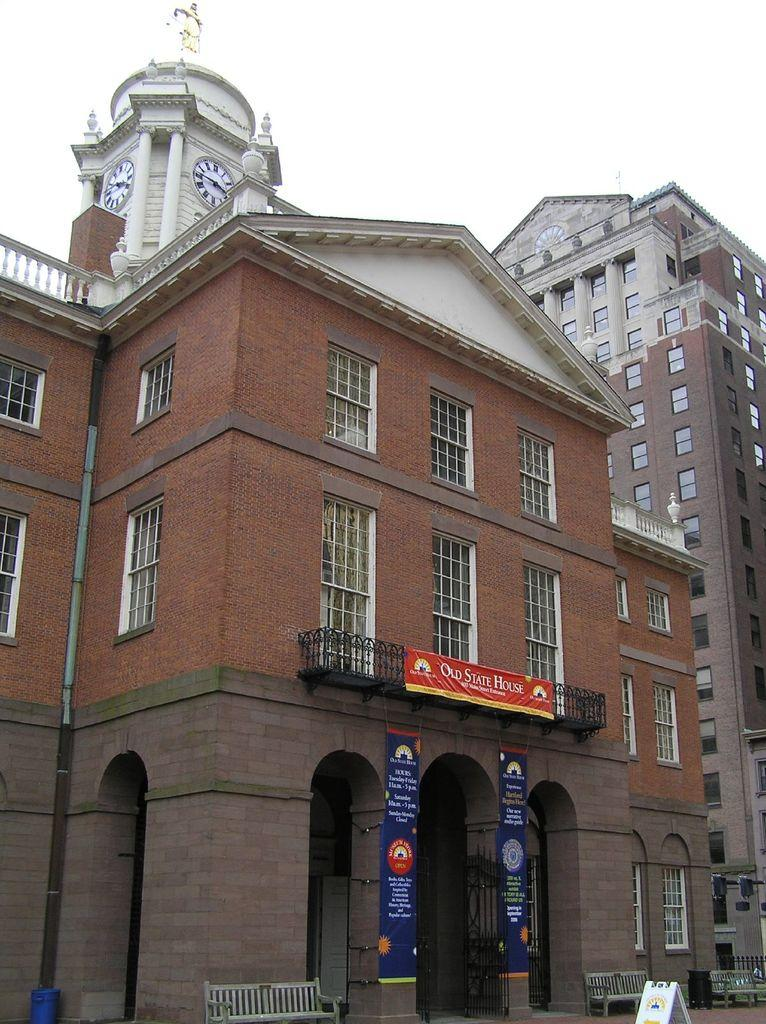What type of structures are present in the image? There are buildings in the image. What can be seen on the buildings? There are clocks and hoardings on the buildings. What is attached to the building? There is a pipe on the building. What is available for people to sit in front of the building? There are benches in front of the building. What is provided for waste disposal in front of the building? There is a dustbin in front of the building. What type of teaching is happening in the image? There is no teaching activity depicted in the image. Is there a fight taking place in the image? There is no fight or any indication of conflict in the image. 